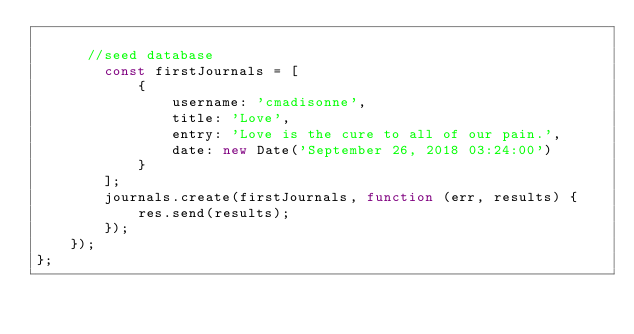Convert code to text. <code><loc_0><loc_0><loc_500><loc_500><_JavaScript_>
      //seed database
        const firstJournals = [
            {
                username: 'cmadisonne',
                title: 'Love',
                entry: 'Love is the cure to all of our pain.',
                date: new Date('September 26, 2018 03:24:00')
            }
        ];
        journals.create(firstJournals, function (err, results) {
            res.send(results);
        });
    });
};

</code> 